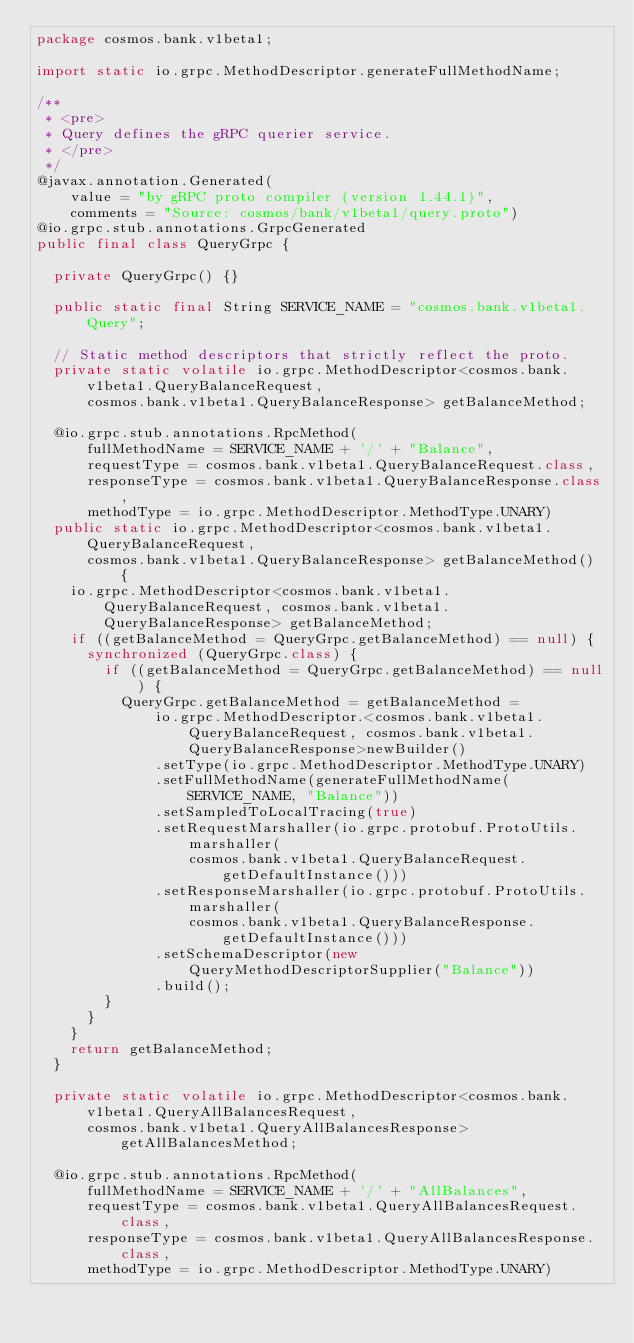<code> <loc_0><loc_0><loc_500><loc_500><_Java_>package cosmos.bank.v1beta1;

import static io.grpc.MethodDescriptor.generateFullMethodName;

/**
 * <pre>
 * Query defines the gRPC querier service.
 * </pre>
 */
@javax.annotation.Generated(
    value = "by gRPC proto compiler (version 1.44.1)",
    comments = "Source: cosmos/bank/v1beta1/query.proto")
@io.grpc.stub.annotations.GrpcGenerated
public final class QueryGrpc {

  private QueryGrpc() {}

  public static final String SERVICE_NAME = "cosmos.bank.v1beta1.Query";

  // Static method descriptors that strictly reflect the proto.
  private static volatile io.grpc.MethodDescriptor<cosmos.bank.v1beta1.QueryBalanceRequest,
      cosmos.bank.v1beta1.QueryBalanceResponse> getBalanceMethod;

  @io.grpc.stub.annotations.RpcMethod(
      fullMethodName = SERVICE_NAME + '/' + "Balance",
      requestType = cosmos.bank.v1beta1.QueryBalanceRequest.class,
      responseType = cosmos.bank.v1beta1.QueryBalanceResponse.class,
      methodType = io.grpc.MethodDescriptor.MethodType.UNARY)
  public static io.grpc.MethodDescriptor<cosmos.bank.v1beta1.QueryBalanceRequest,
      cosmos.bank.v1beta1.QueryBalanceResponse> getBalanceMethod() {
    io.grpc.MethodDescriptor<cosmos.bank.v1beta1.QueryBalanceRequest, cosmos.bank.v1beta1.QueryBalanceResponse> getBalanceMethod;
    if ((getBalanceMethod = QueryGrpc.getBalanceMethod) == null) {
      synchronized (QueryGrpc.class) {
        if ((getBalanceMethod = QueryGrpc.getBalanceMethod) == null) {
          QueryGrpc.getBalanceMethod = getBalanceMethod =
              io.grpc.MethodDescriptor.<cosmos.bank.v1beta1.QueryBalanceRequest, cosmos.bank.v1beta1.QueryBalanceResponse>newBuilder()
              .setType(io.grpc.MethodDescriptor.MethodType.UNARY)
              .setFullMethodName(generateFullMethodName(SERVICE_NAME, "Balance"))
              .setSampledToLocalTracing(true)
              .setRequestMarshaller(io.grpc.protobuf.ProtoUtils.marshaller(
                  cosmos.bank.v1beta1.QueryBalanceRequest.getDefaultInstance()))
              .setResponseMarshaller(io.grpc.protobuf.ProtoUtils.marshaller(
                  cosmos.bank.v1beta1.QueryBalanceResponse.getDefaultInstance()))
              .setSchemaDescriptor(new QueryMethodDescriptorSupplier("Balance"))
              .build();
        }
      }
    }
    return getBalanceMethod;
  }

  private static volatile io.grpc.MethodDescriptor<cosmos.bank.v1beta1.QueryAllBalancesRequest,
      cosmos.bank.v1beta1.QueryAllBalancesResponse> getAllBalancesMethod;

  @io.grpc.stub.annotations.RpcMethod(
      fullMethodName = SERVICE_NAME + '/' + "AllBalances",
      requestType = cosmos.bank.v1beta1.QueryAllBalancesRequest.class,
      responseType = cosmos.bank.v1beta1.QueryAllBalancesResponse.class,
      methodType = io.grpc.MethodDescriptor.MethodType.UNARY)</code> 